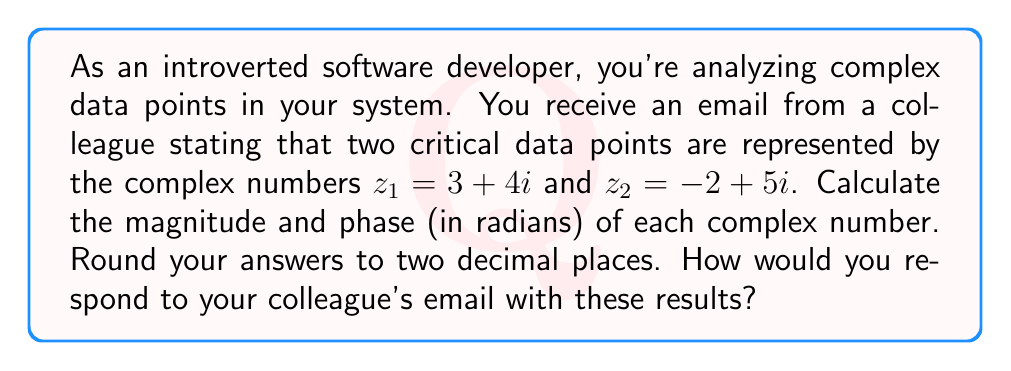Solve this math problem. To calculate the magnitude and phase of complex numbers, we use the following formulas:

1. Magnitude: $|z| = \sqrt{a^2 + b^2}$, where $z = a + bi$
2. Phase: $\theta = \tan^{-1}(\frac{b}{a})$, where $z = a + bi$

For $z_1 = 3 + 4i$:

Magnitude:
$$|z_1| = \sqrt{3^2 + 4^2} = \sqrt{9 + 16} = \sqrt{25} = 5$$

Phase:
$$\theta_1 = \tan^{-1}(\frac{4}{3}) \approx 0.93 \text{ radians}$$

For $z_2 = -2 + 5i$:

Magnitude:
$$|z_2| = \sqrt{(-2)^2 + 5^2} = \sqrt{4 + 25} = \sqrt{29} \approx 5.39$$

Phase:
$$\theta_2 = \tan^{-1}(\frac{5}{-2}) + \pi \approx -1.19 + \pi \approx 1.95 \text{ radians}$$

Note: We add $\pi$ to the result of $\tan^{-1}(\frac{5}{-2})$ because the point is in the second quadrant.

Rounding all results to two decimal places:
$|z_1| = 5.00$
$\theta_1 = 0.93$ radians
$|z_2| = 5.39$
$\theta_2 = 1.95$ radians
Answer: The magnitude and phase of $z_1 = 3 + 4i$ are 5.00 and 0.93 radians, respectively. For $z_2 = -2 + 5i$, the magnitude is 5.39 and the phase is 1.95 radians. You would respond to your colleague's email with these calculated values, providing a concise summary of the results for both complex numbers. 